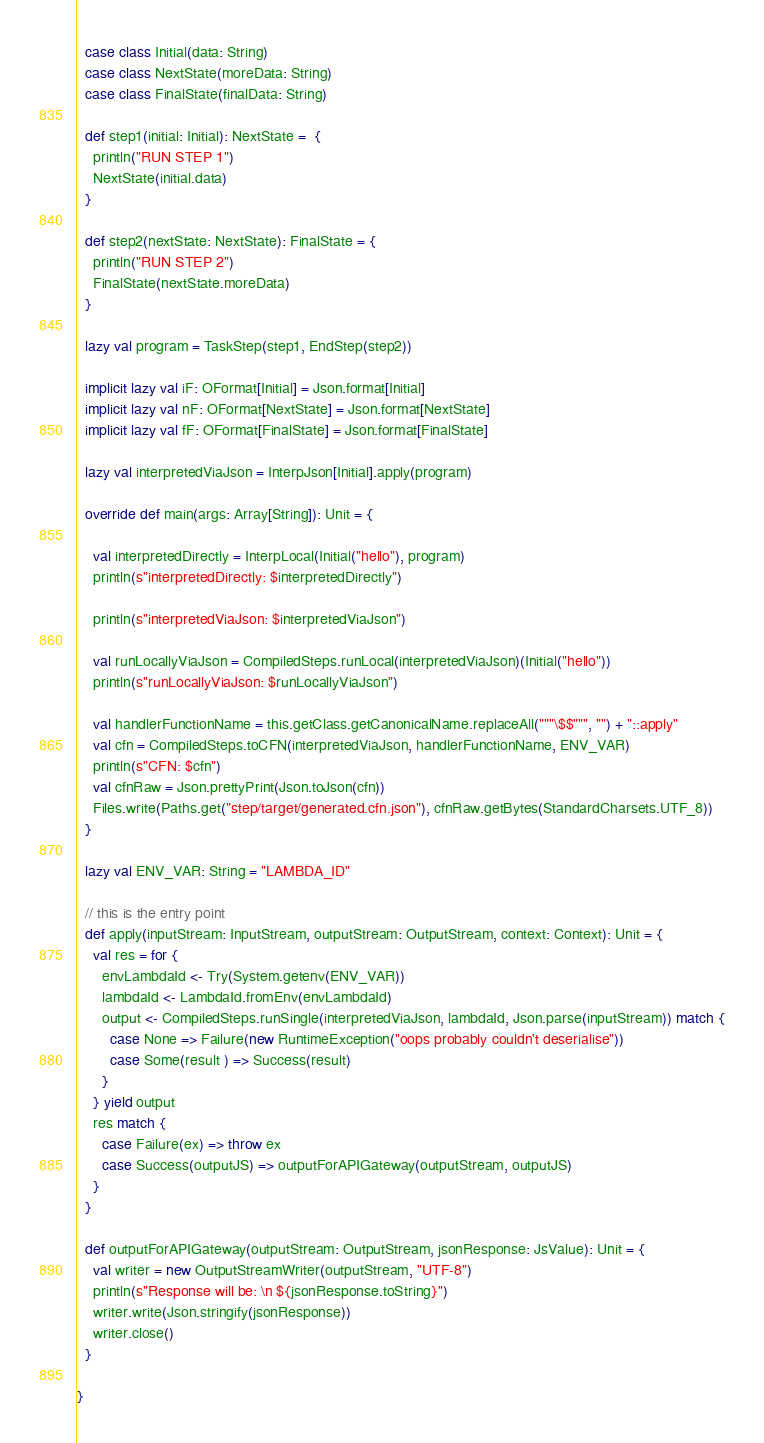<code> <loc_0><loc_0><loc_500><loc_500><_Scala_>  case class Initial(data: String)
  case class NextState(moreData: String)
  case class FinalState(finalData: String)

  def step1(initial: Initial): NextState =  {
    println("RUN STEP 1")
    NextState(initial.data)
  }

  def step2(nextState: NextState): FinalState = {
    println("RUN STEP 2")
    FinalState(nextState.moreData)
  }

  lazy val program = TaskStep(step1, EndStep(step2))

  implicit lazy val iF: OFormat[Initial] = Json.format[Initial]
  implicit lazy val nF: OFormat[NextState] = Json.format[NextState]
  implicit lazy val fF: OFormat[FinalState] = Json.format[FinalState]

  lazy val interpretedViaJson = InterpJson[Initial].apply(program)

  override def main(args: Array[String]): Unit = {

    val interpretedDirectly = InterpLocal(Initial("hello"), program)
    println(s"interpretedDirectly: $interpretedDirectly")

    println(s"interpretedViaJson: $interpretedViaJson")

    val runLocallyViaJson = CompiledSteps.runLocal(interpretedViaJson)(Initial("hello"))
    println(s"runLocallyViaJson: $runLocallyViaJson")

    val handlerFunctionName = this.getClass.getCanonicalName.replaceAll("""\$$""", "") + "::apply"
    val cfn = CompiledSteps.toCFN(interpretedViaJson, handlerFunctionName, ENV_VAR)
    println(s"CFN: $cfn")
    val cfnRaw = Json.prettyPrint(Json.toJson(cfn))
    Files.write(Paths.get("step/target/generated.cfn.json"), cfnRaw.getBytes(StandardCharsets.UTF_8))
  }

  lazy val ENV_VAR: String = "LAMBDA_ID"

  // this is the entry point
  def apply(inputStream: InputStream, outputStream: OutputStream, context: Context): Unit = {
    val res = for {
      envLambdaId <- Try(System.getenv(ENV_VAR))
      lambdaId <- LambdaId.fromEnv(envLambdaId)
      output <- CompiledSteps.runSingle(interpretedViaJson, lambdaId, Json.parse(inputStream)) match {
        case None => Failure(new RuntimeException("oops probably couldn't deserialise"))
        case Some(result ) => Success(result)
      }
    } yield output
    res match {
      case Failure(ex) => throw ex
      case Success(outputJS) => outputForAPIGateway(outputStream, outputJS)
    }
  }

  def outputForAPIGateway(outputStream: OutputStream, jsonResponse: JsValue): Unit = {
    val writer = new OutputStreamWriter(outputStream, "UTF-8")
    println(s"Response will be: \n ${jsonResponse.toString}")
    writer.write(Json.stringify(jsonResponse))
    writer.close()
  }

}

</code> 